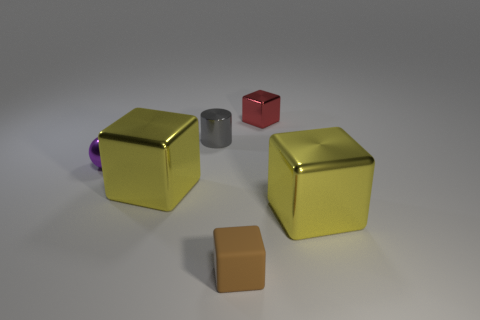Subtract all metallic blocks. How many blocks are left? 1 Add 3 small blue shiny cubes. How many objects exist? 9 Subtract all yellow blocks. How many blocks are left? 2 Subtract 1 spheres. How many spheres are left? 0 Subtract 0 green cubes. How many objects are left? 6 Subtract all spheres. How many objects are left? 5 Subtract all brown cylinders. Subtract all yellow cubes. How many cylinders are left? 1 Subtract all purple spheres. How many cyan cubes are left? 0 Subtract all matte cubes. Subtract all small rubber things. How many objects are left? 4 Add 5 small brown matte things. How many small brown matte things are left? 6 